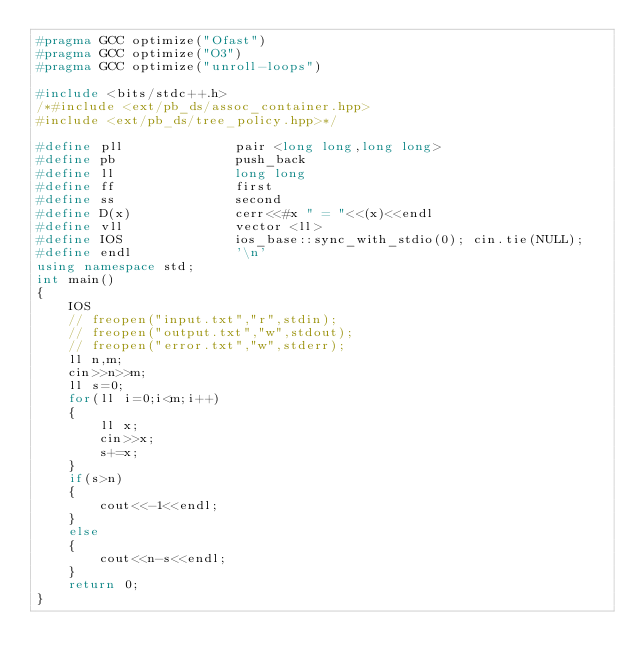<code> <loc_0><loc_0><loc_500><loc_500><_C++_>#pragma GCC optimize("Ofast")
#pragma GCC optimize("O3")
#pragma GCC optimize("unroll-loops")

#include <bits/stdc++.h>
/*#include <ext/pb_ds/assoc_container.hpp>
#include <ext/pb_ds/tree_policy.hpp>*/
 
#define pll              pair <long long,long long>
#define pb               push_back
#define ll               long long
#define ff               first
#define ss               second
#define D(x)             cerr<<#x " = "<<(x)<<endl
#define vll              vector <ll>
#define IOS              ios_base::sync_with_stdio(0); cin.tie(NULL);
#define endl             '\n'   
using namespace std;
int main()
{
    IOS
 	// freopen("input.txt","r",stdin);
 	// freopen("output.txt","w",stdout);
 	// freopen("error.txt","w",stderr);
 	ll n,m;
 	cin>>n>>m;
 	ll s=0;
 	for(ll i=0;i<m;i++)
 	{
 		ll x;
 		cin>>x;
 		s+=x;
 	}
 	if(s>n)
 	{
 		cout<<-1<<endl;
 	}
 	else
 	{
 		cout<<n-s<<endl;
 	}
    return 0;
}</code> 